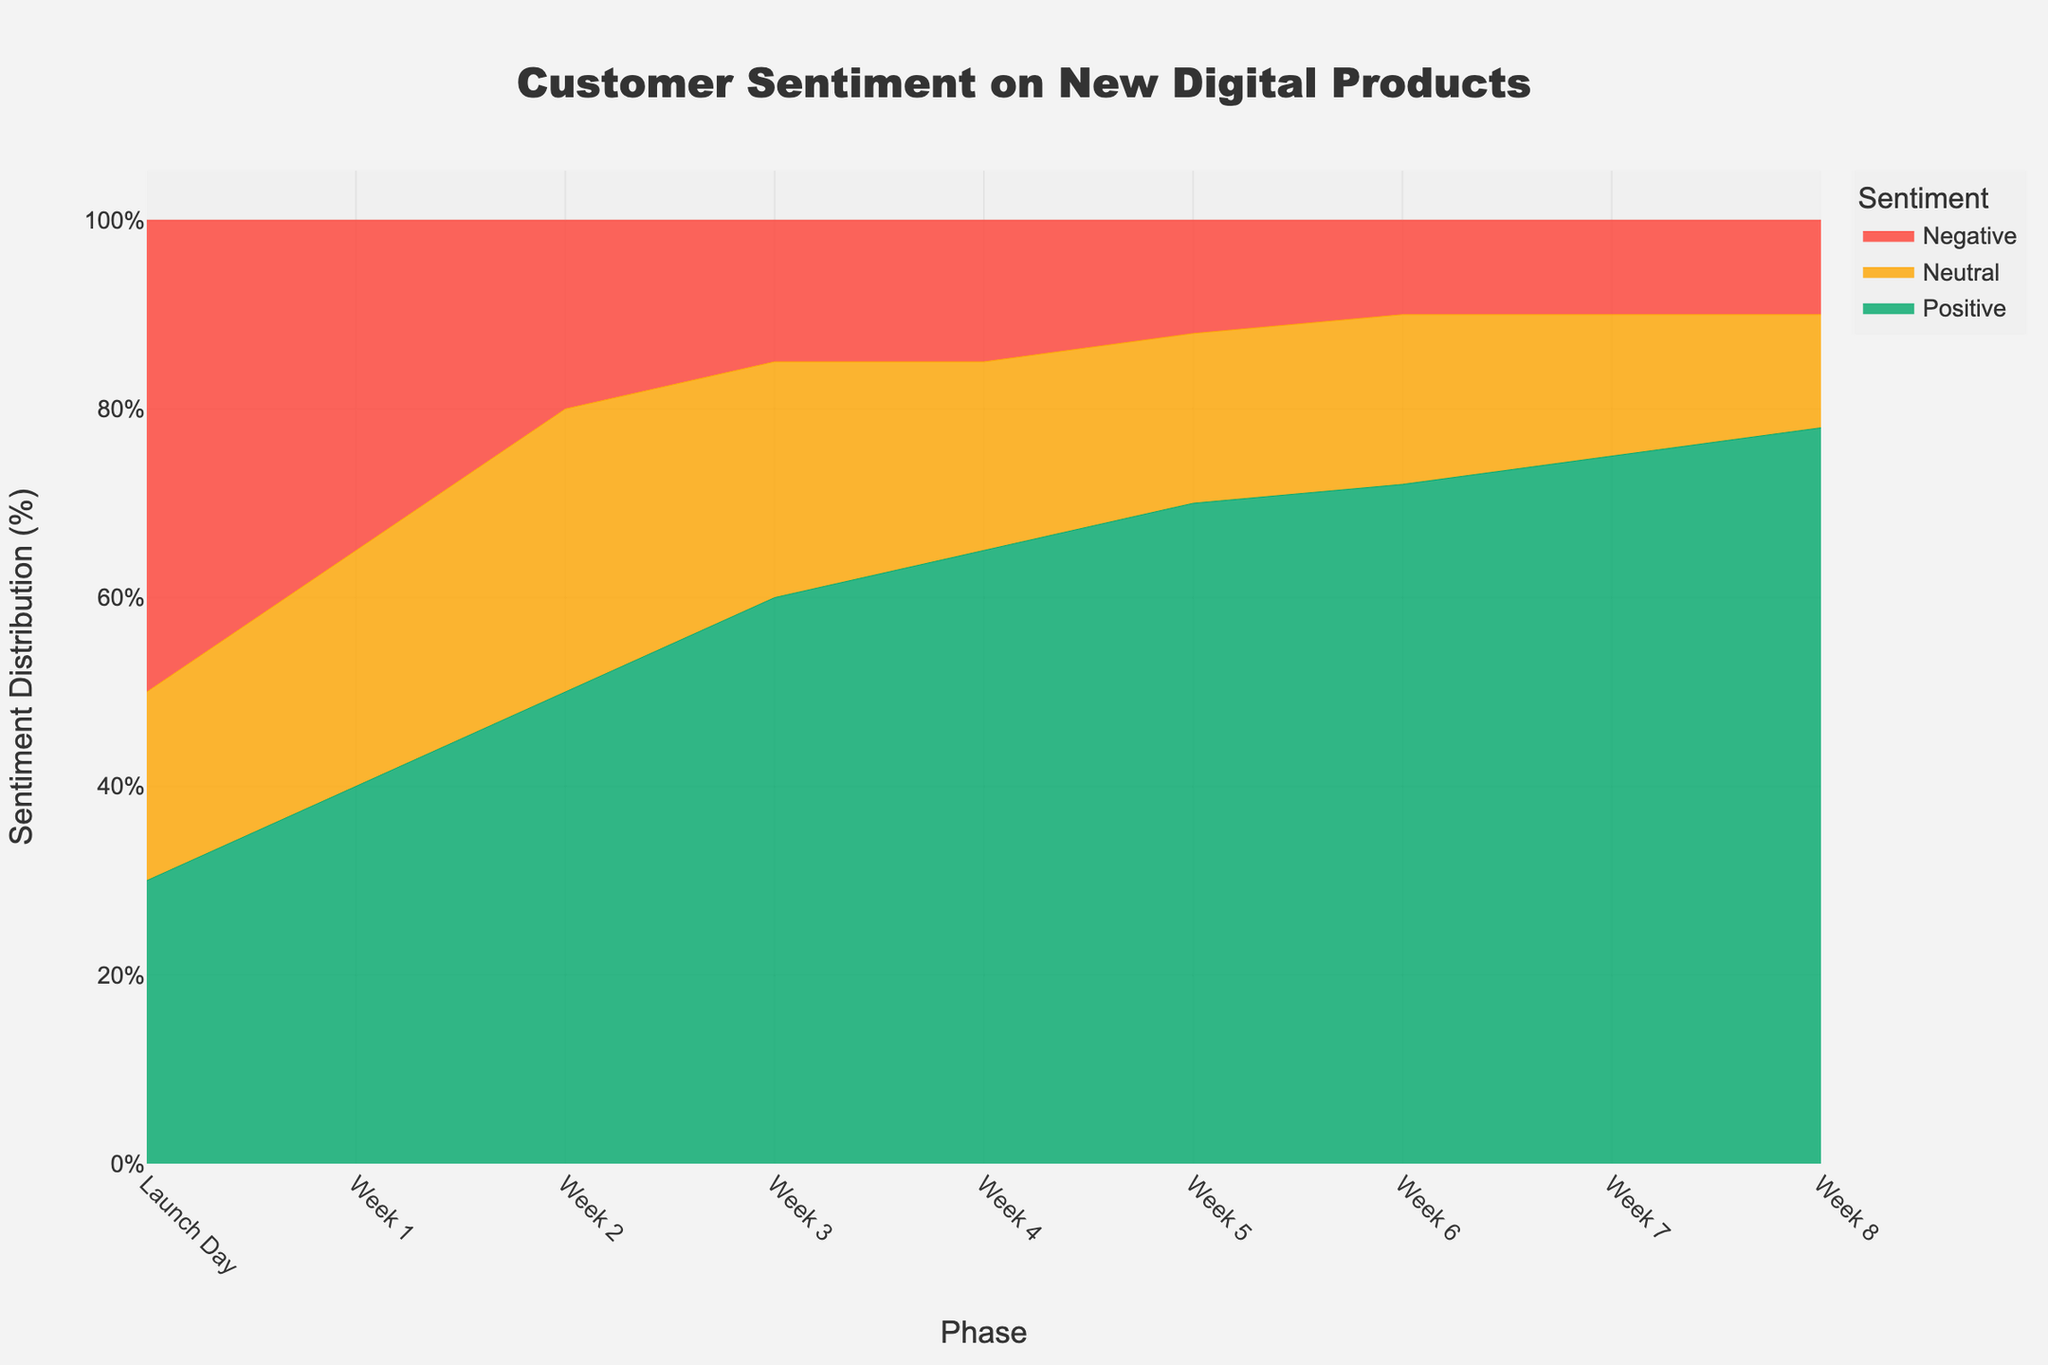What's the title of the figure? The title is located at the top of the figure, centered and in large bold text. It reads "Customer Sentiment on New Digital Products," indicating the main focus of the data visualization.
Answer: Customer Sentiment on New Digital Products How many phases are displayed on the x-axis of the chart? The x-axis lists different phases over time, starting from "Launch Day" and ending at "Week 8." Counting these labels gives us the total number of phases.
Answer: 9 How does the proportion of positive sentiment change from Launch Day to Week 8? At Launch Day, the positive sentiment is 30%, and it gradually increases through the weeks. Inspecting each phase, the positive sentiment rises to 78% by Week 8.
Answer: It increases Which sentiment category has the highest value during Launch Day? Observing the stack at the "Launch Day" phase reveals that the largest area belongs to the negative sentiment. This suggests that negative sentiment had the highest value.
Answer: Negative Compare the neutral sentiment between Week 1 and Week 7. Which one is higher? By comparing the height of the neutral sentiment area at "Week 1" (which is 25%) and "Week 7" (which is 15%), we can see that Week 1 has a higher neutral sentiment.
Answer: Week 1 What is the trend of negative sentiment over the phases? Starting from 50% at Launch Day, the negative sentiment declines over subsequent weeks down to 10% by Week 8. This indicates a downward trend.
Answer: It decreases Which phase shows the highest positive sentiment? Checking the data at each phase reveals that the highest positive sentiment occurs at "Week 8" with a value of 78%.
Answer: Week 8 How much did the positive sentiment increase from Week 1 to Week 2? The positive sentiment at Week 1 is 40% and at Week 2 is 50%. The difference between these two gives the increase. 50% - 40% = 10%.
Answer: 10% In which week does the positive sentiment first exceed 60%? The first phase where the positive sentiment exceeds 60% is "Week 3" with precisely 60%.
Answer: Week 3 What is the sum of positive and neutral sentiments in Week 5? The positive sentiment in Week 5 is 70%, and the neutral sentiment is 18%. Adding both values gives us the sum, 70% + 18% = 88%.
Answer: 88% 